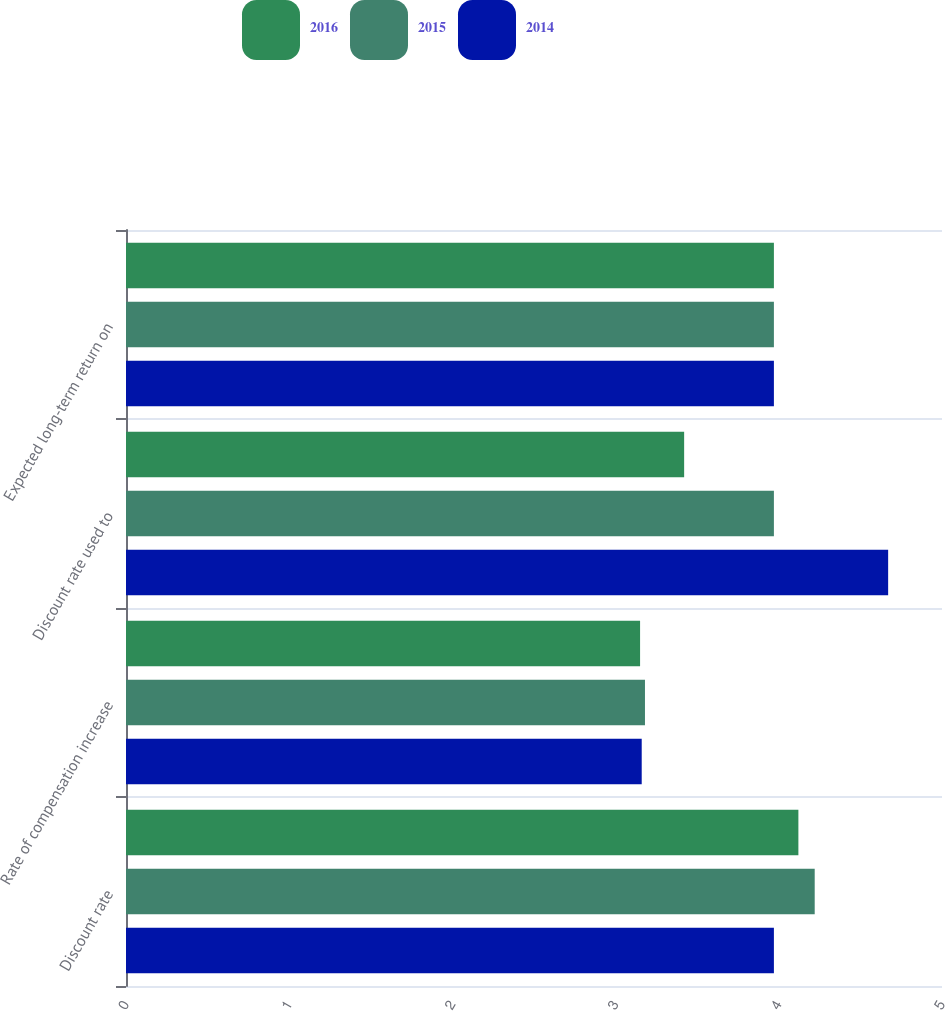<chart> <loc_0><loc_0><loc_500><loc_500><stacked_bar_chart><ecel><fcel>Discount rate<fcel>Rate of compensation increase<fcel>Discount rate used to<fcel>Expected long-term return on<nl><fcel>2016<fcel>4.12<fcel>3.15<fcel>3.42<fcel>3.97<nl><fcel>2015<fcel>4.22<fcel>3.18<fcel>3.97<fcel>3.97<nl><fcel>2014<fcel>3.97<fcel>3.16<fcel>4.67<fcel>3.97<nl></chart> 